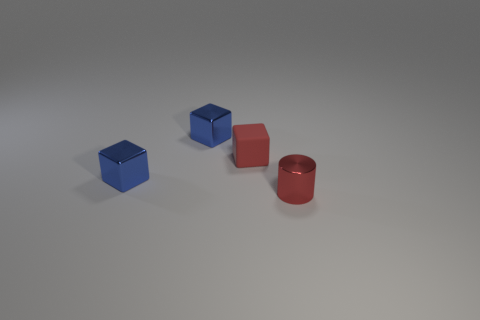Subtract all red rubber cubes. How many cubes are left? 2 Subtract all red cubes. How many cubes are left? 2 Subtract 2 blocks. How many blocks are left? 1 Subtract all red balls. How many purple cylinders are left? 0 Add 2 metallic things. How many objects exist? 6 Subtract 0 purple spheres. How many objects are left? 4 Subtract all blocks. How many objects are left? 1 Subtract all yellow cylinders. Subtract all yellow blocks. How many cylinders are left? 1 Subtract all tiny blue objects. Subtract all tiny red shiny cylinders. How many objects are left? 1 Add 4 red metal things. How many red metal things are left? 5 